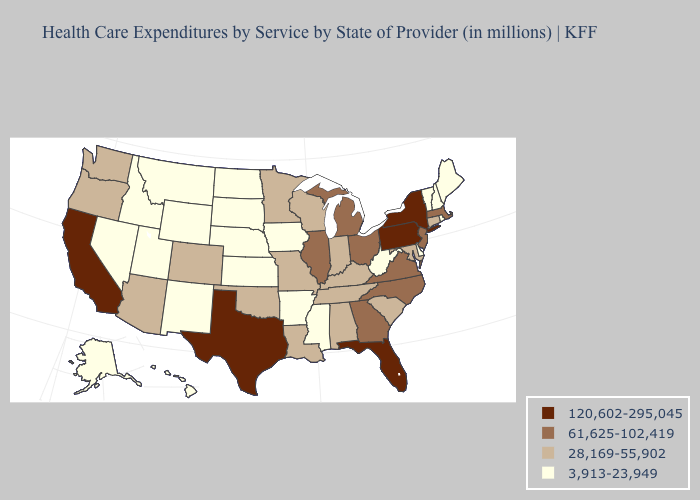What is the highest value in the MidWest ?
Keep it brief. 61,625-102,419. Does Pennsylvania have the highest value in the USA?
Quick response, please. Yes. What is the lowest value in the South?
Write a very short answer. 3,913-23,949. Name the states that have a value in the range 3,913-23,949?
Quick response, please. Alaska, Arkansas, Delaware, Hawaii, Idaho, Iowa, Kansas, Maine, Mississippi, Montana, Nebraska, Nevada, New Hampshire, New Mexico, North Dakota, Rhode Island, South Dakota, Utah, Vermont, West Virginia, Wyoming. Among the states that border Alabama , which have the lowest value?
Quick response, please. Mississippi. What is the highest value in the West ?
Short answer required. 120,602-295,045. What is the highest value in states that border Utah?
Quick response, please. 28,169-55,902. What is the lowest value in the USA?
Quick response, please. 3,913-23,949. Among the states that border Kansas , which have the lowest value?
Keep it brief. Nebraska. Does the map have missing data?
Give a very brief answer. No. What is the highest value in the USA?
Short answer required. 120,602-295,045. Among the states that border Iowa , does Minnesota have the highest value?
Short answer required. No. Name the states that have a value in the range 120,602-295,045?
Short answer required. California, Florida, New York, Pennsylvania, Texas. Name the states that have a value in the range 3,913-23,949?
Be succinct. Alaska, Arkansas, Delaware, Hawaii, Idaho, Iowa, Kansas, Maine, Mississippi, Montana, Nebraska, Nevada, New Hampshire, New Mexico, North Dakota, Rhode Island, South Dakota, Utah, Vermont, West Virginia, Wyoming. Name the states that have a value in the range 28,169-55,902?
Answer briefly. Alabama, Arizona, Colorado, Connecticut, Indiana, Kentucky, Louisiana, Maryland, Minnesota, Missouri, Oklahoma, Oregon, South Carolina, Tennessee, Washington, Wisconsin. 